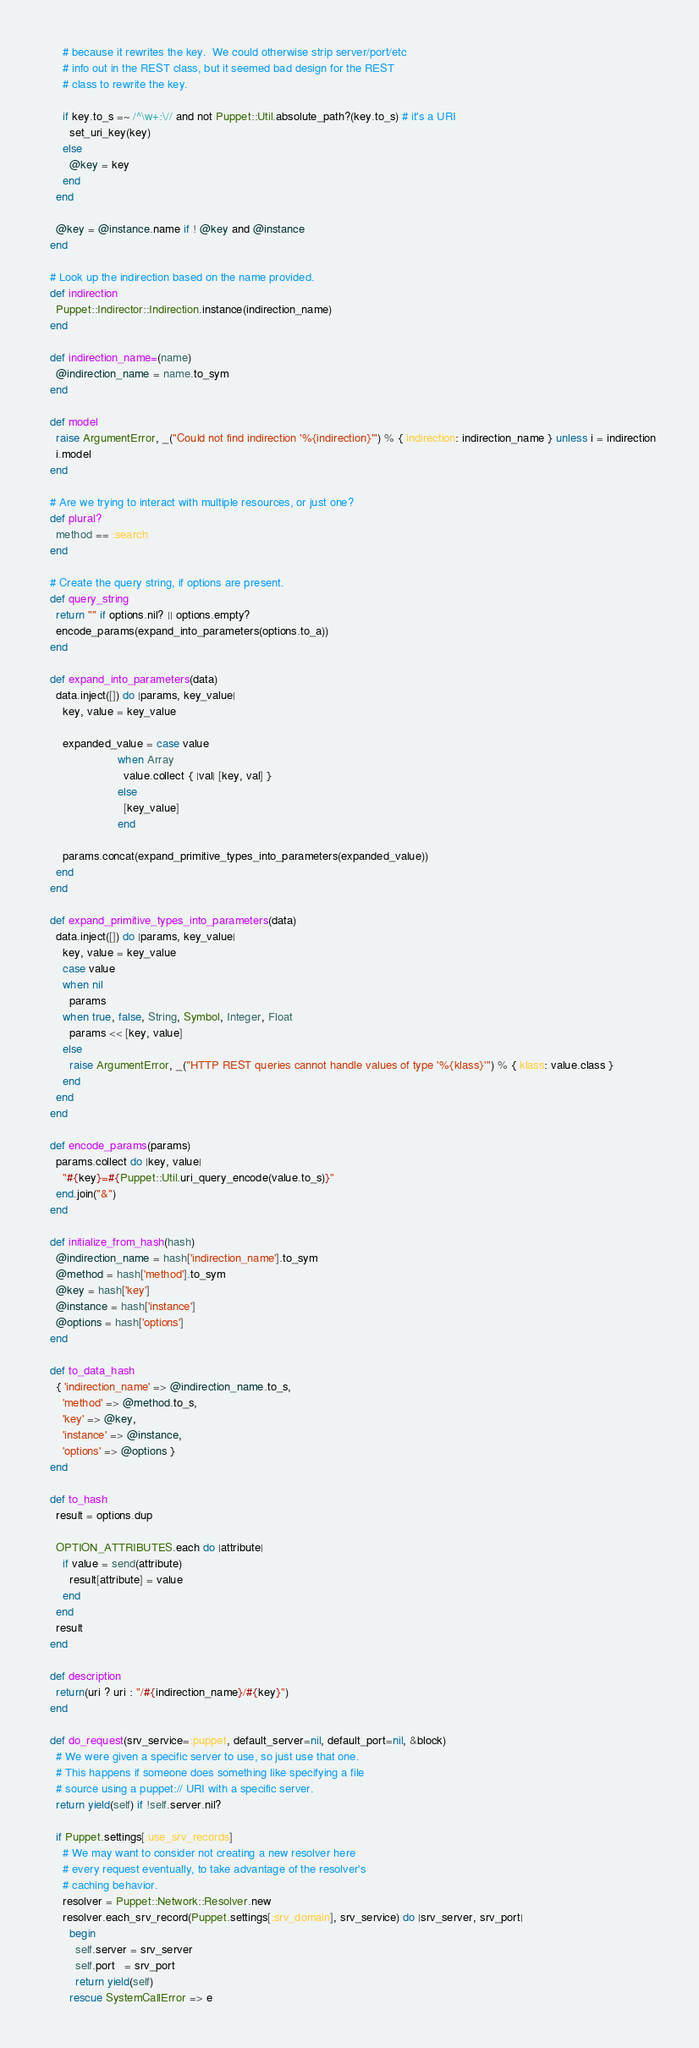Convert code to text. <code><loc_0><loc_0><loc_500><loc_500><_Ruby_>      # because it rewrites the key.  We could otherwise strip server/port/etc
      # info out in the REST class, but it seemed bad design for the REST
      # class to rewrite the key.

      if key.to_s =~ /^\w+:\// and not Puppet::Util.absolute_path?(key.to_s) # it's a URI
        set_uri_key(key)
      else
        @key = key
      end
    end

    @key = @instance.name if ! @key and @instance
  end

  # Look up the indirection based on the name provided.
  def indirection
    Puppet::Indirector::Indirection.instance(indirection_name)
  end

  def indirection_name=(name)
    @indirection_name = name.to_sym
  end

  def model
    raise ArgumentError, _("Could not find indirection '%{indirection}'") % { indirection: indirection_name } unless i = indirection
    i.model
  end

  # Are we trying to interact with multiple resources, or just one?
  def plural?
    method == :search
  end

  # Create the query string, if options are present.
  def query_string
    return "" if options.nil? || options.empty?
    encode_params(expand_into_parameters(options.to_a))
  end

  def expand_into_parameters(data)
    data.inject([]) do |params, key_value|
      key, value = key_value

      expanded_value = case value
                       when Array
                         value.collect { |val| [key, val] }
                       else
                         [key_value]
                       end

      params.concat(expand_primitive_types_into_parameters(expanded_value))
    end
  end

  def expand_primitive_types_into_parameters(data)
    data.inject([]) do |params, key_value|
      key, value = key_value
      case value
      when nil
        params
      when true, false, String, Symbol, Integer, Float
        params << [key, value]
      else
        raise ArgumentError, _("HTTP REST queries cannot handle values of type '%{klass}'") % { klass: value.class }
      end
    end
  end

  def encode_params(params)
    params.collect do |key, value|
      "#{key}=#{Puppet::Util.uri_query_encode(value.to_s)}"
    end.join("&")
  end

  def initialize_from_hash(hash)
    @indirection_name = hash['indirection_name'].to_sym
    @method = hash['method'].to_sym
    @key = hash['key']
    @instance = hash['instance']
    @options = hash['options']
  end

  def to_data_hash
    { 'indirection_name' => @indirection_name.to_s,
      'method' => @method.to_s,
      'key' => @key,
      'instance' => @instance,
      'options' => @options }
  end

  def to_hash
    result = options.dup

    OPTION_ATTRIBUTES.each do |attribute|
      if value = send(attribute)
        result[attribute] = value
      end
    end
    result
  end

  def description
    return(uri ? uri : "/#{indirection_name}/#{key}")
  end

  def do_request(srv_service=:puppet, default_server=nil, default_port=nil, &block)
    # We were given a specific server to use, so just use that one.
    # This happens if someone does something like specifying a file
    # source using a puppet:// URI with a specific server.
    return yield(self) if !self.server.nil?

    if Puppet.settings[:use_srv_records]
      # We may want to consider not creating a new resolver here
      # every request eventually, to take advantage of the resolver's
      # caching behavior.
      resolver = Puppet::Network::Resolver.new
      resolver.each_srv_record(Puppet.settings[:srv_domain], srv_service) do |srv_server, srv_port|
        begin
          self.server = srv_server
          self.port   = srv_port
          return yield(self)
        rescue SystemCallError => e</code> 